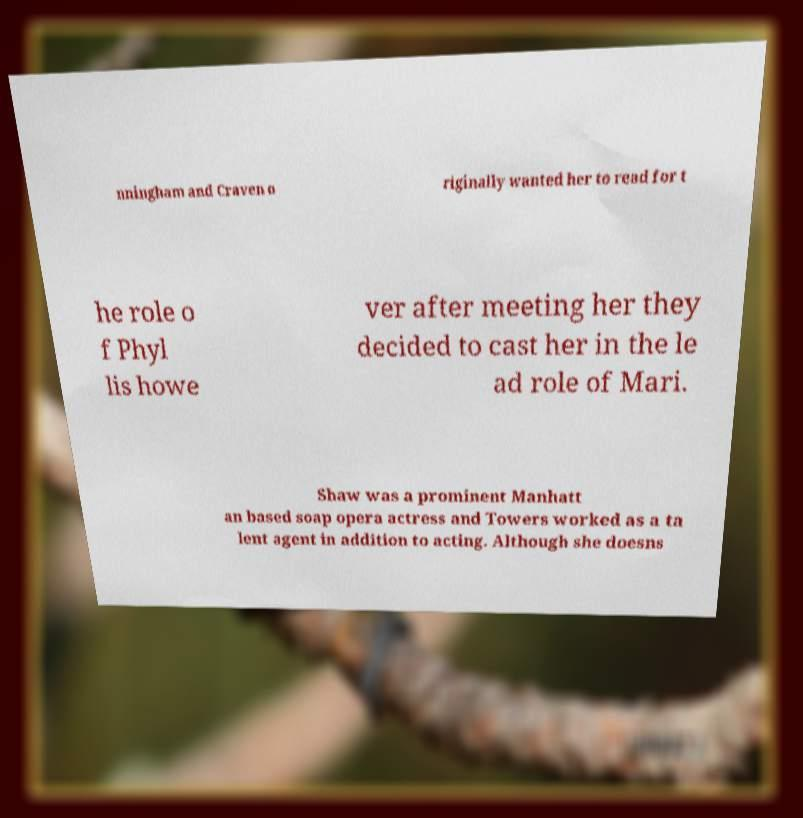For documentation purposes, I need the text within this image transcribed. Could you provide that? nningham and Craven o riginally wanted her to read for t he role o f Phyl lis howe ver after meeting her they decided to cast her in the le ad role of Mari. Shaw was a prominent Manhatt an based soap opera actress and Towers worked as a ta lent agent in addition to acting. Although she doesns 